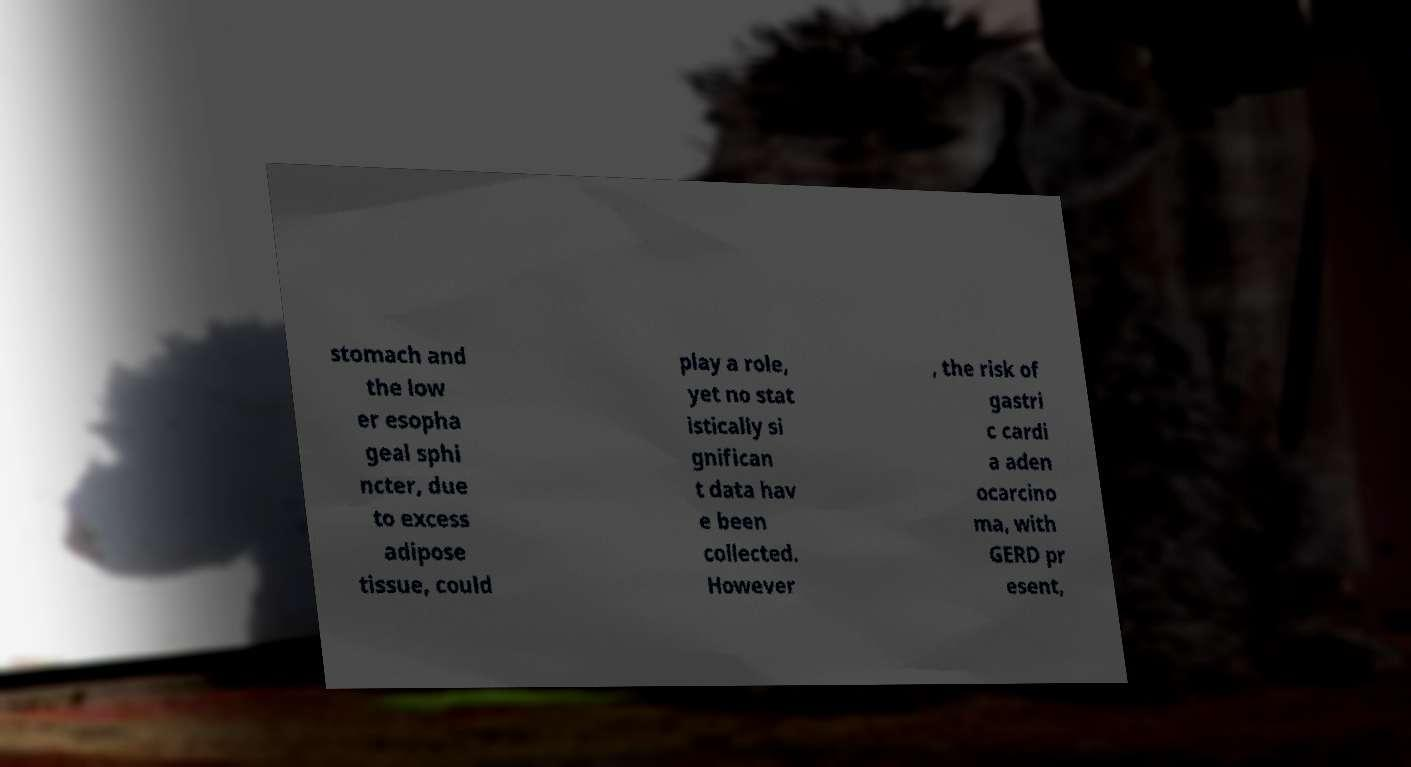Can you accurately transcribe the text from the provided image for me? stomach and the low er esopha geal sphi ncter, due to excess adipose tissue, could play a role, yet no stat istically si gnifican t data hav e been collected. However , the risk of gastri c cardi a aden ocarcino ma, with GERD pr esent, 